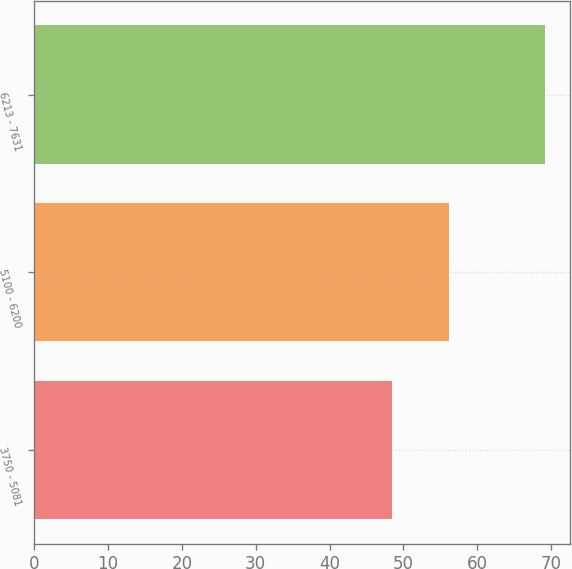<chart> <loc_0><loc_0><loc_500><loc_500><bar_chart><fcel>3750 - 5081<fcel>5100 - 6200<fcel>6213 - 7631<nl><fcel>48.43<fcel>56.18<fcel>69.14<nl></chart> 